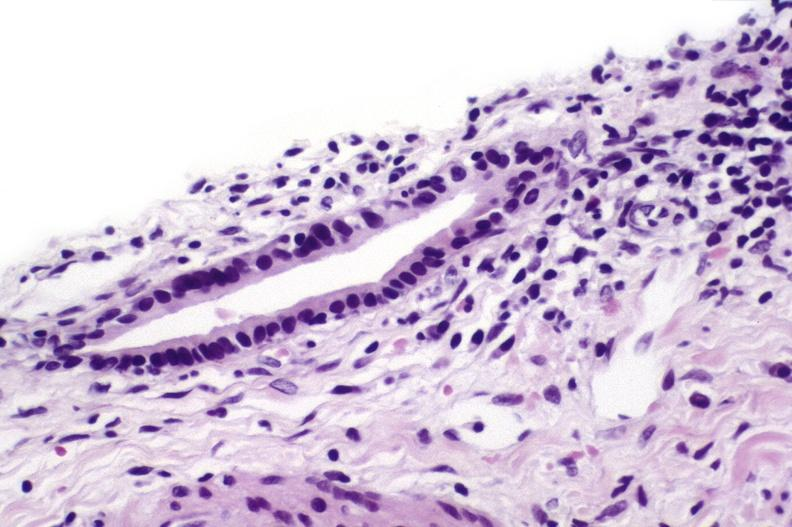what is present?
Answer the question using a single word or phrase. Hepatobiliary 